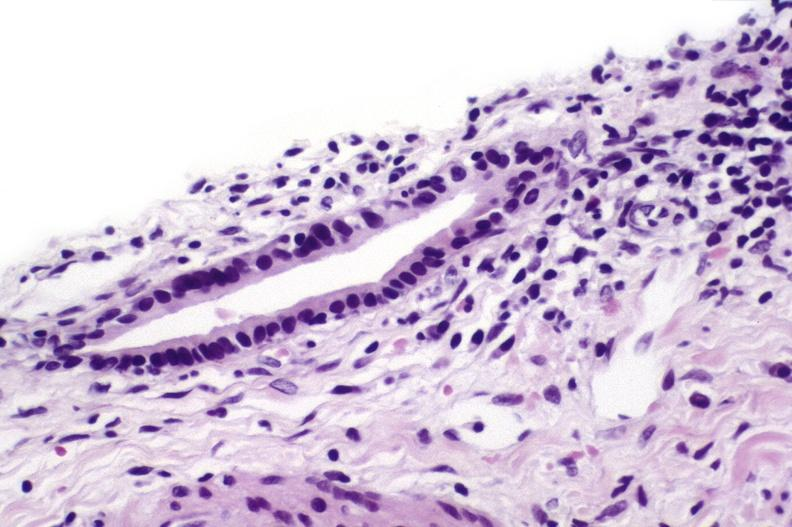what is present?
Answer the question using a single word or phrase. Hepatobiliary 